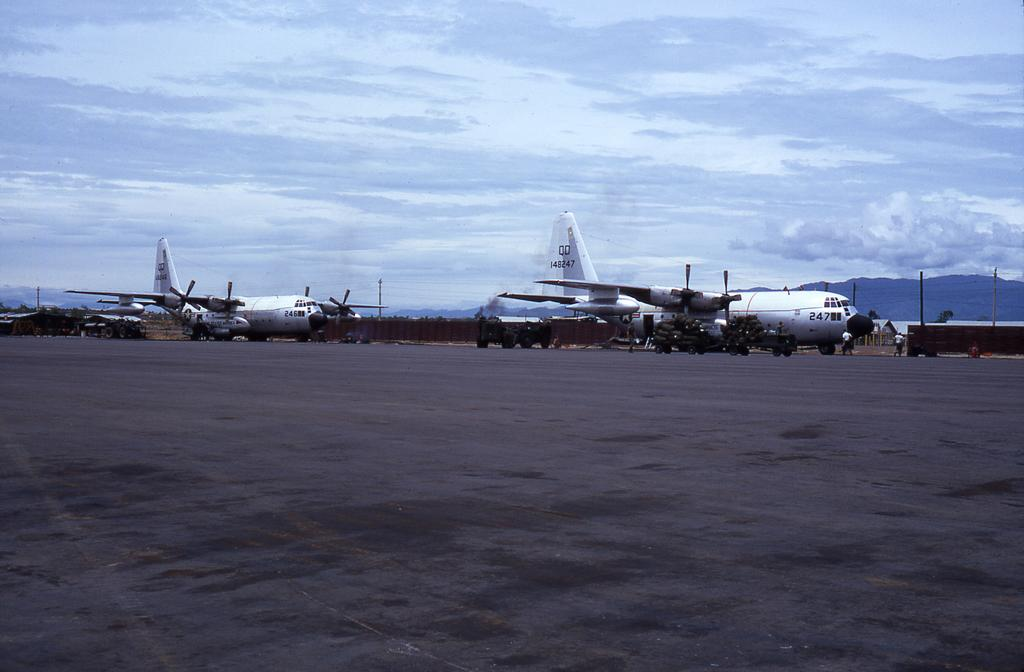What is the main subject of the image? The main subject of the image is a group of airplanes. Where are the airplanes located in the image? The airplanes are placed on the ground. What can be seen in the background of the image? There are mountains and a group of persons in the background of the image. How would you describe the sky in the image? The sky is cloudy in the background of the image. How many girls are standing next to the airplanes in the image? There is no mention of girls in the image; it features a group of airplanes on the ground with mountains and a group of persons in the background. 